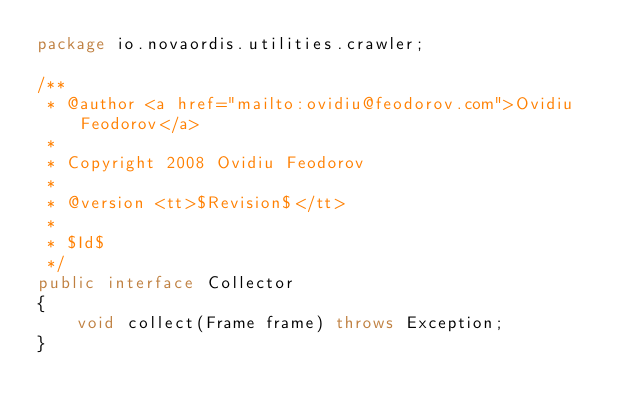<code> <loc_0><loc_0><loc_500><loc_500><_Java_>package io.novaordis.utilities.crawler;

/**
 * @author <a href="mailto:ovidiu@feodorov.com">Ovidiu Feodorov</a>
 *
 * Copyright 2008 Ovidiu Feodorov
 *
 * @version <tt>$Revision$</tt>
 *
 * $Id$
 */
public interface Collector
{
    void collect(Frame frame) throws Exception;
}
</code> 